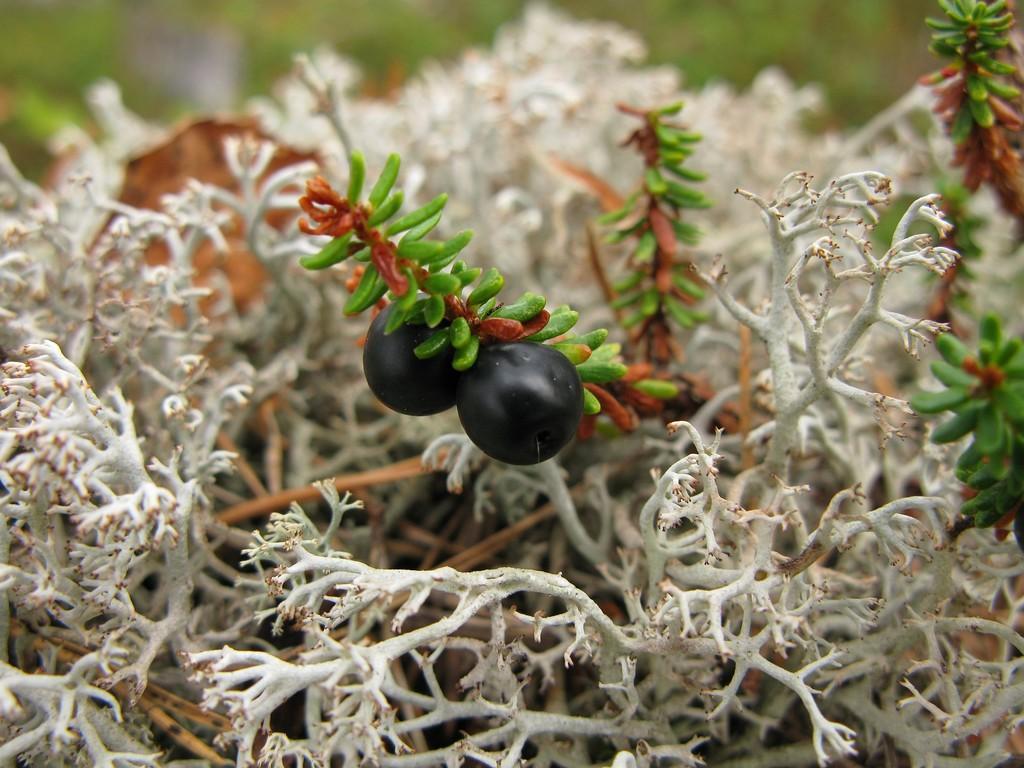How would you summarize this image in a sentence or two? In the center of the image there are grapes to the plant. 